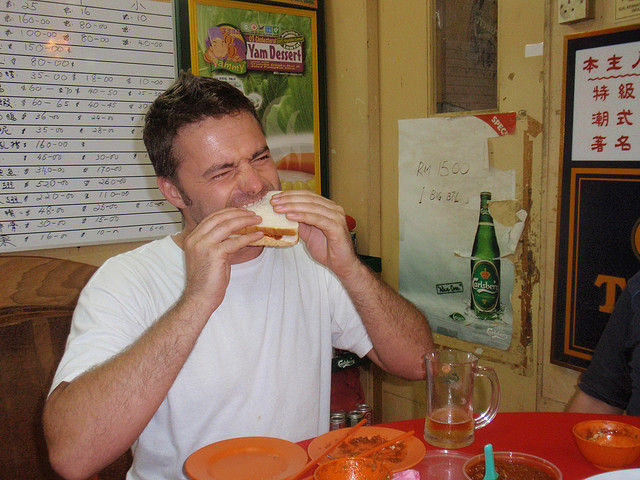Please extract the text content from this image. Yam Dessert T Yammy 114 25-00 110-00 05-00 160-00 35-00 36 40-45 1 8-00 35-00 150-00 80-00 80-00 10 25 SPEC 1500 